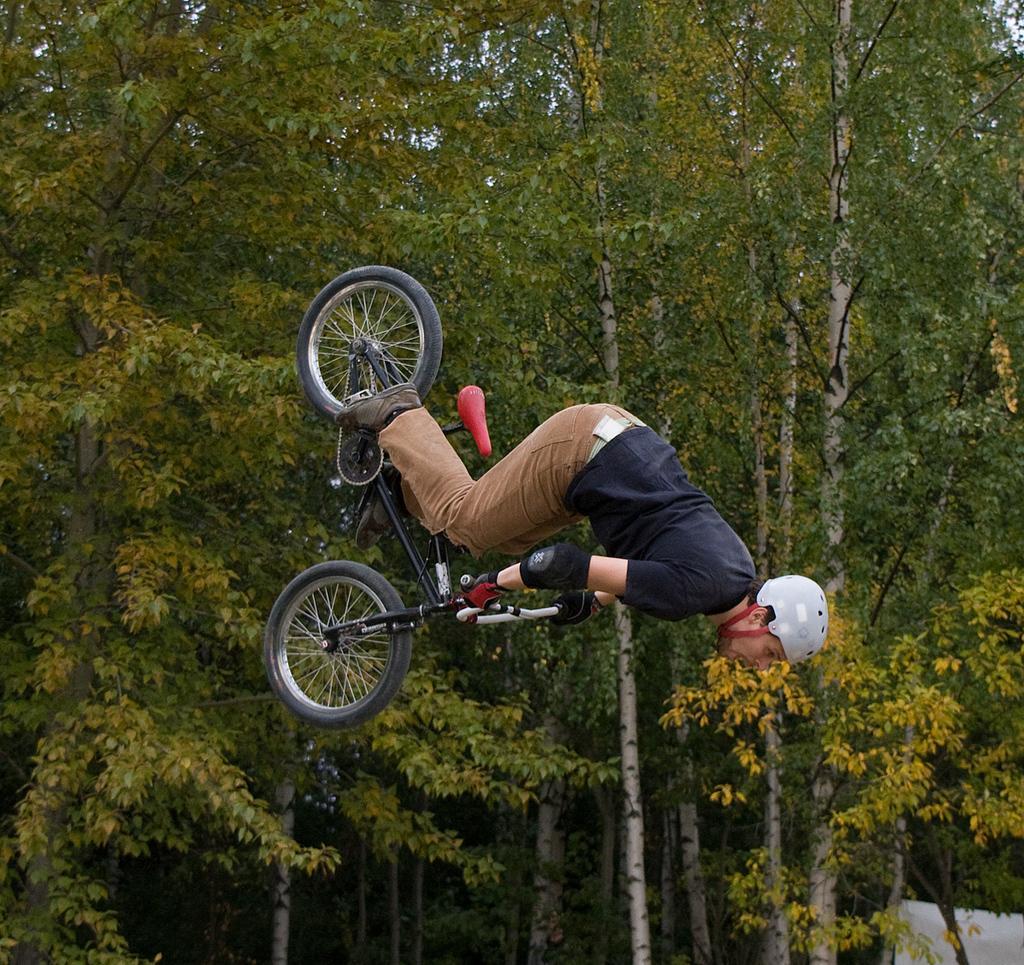Can you describe this image briefly? In the picture we can see a man jumping by holding a bicycle with the hands, there are trees. 